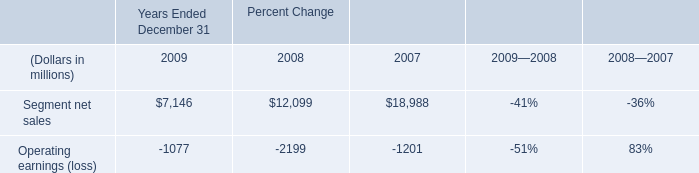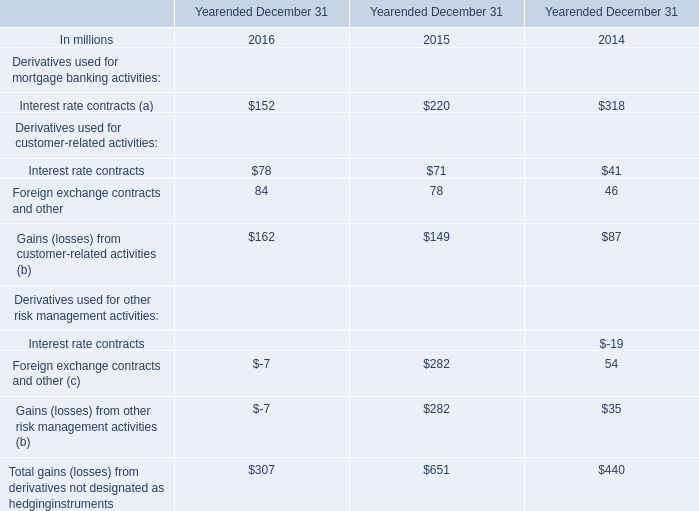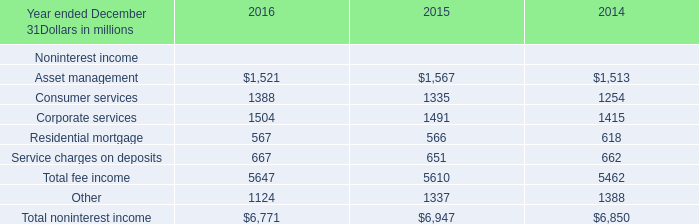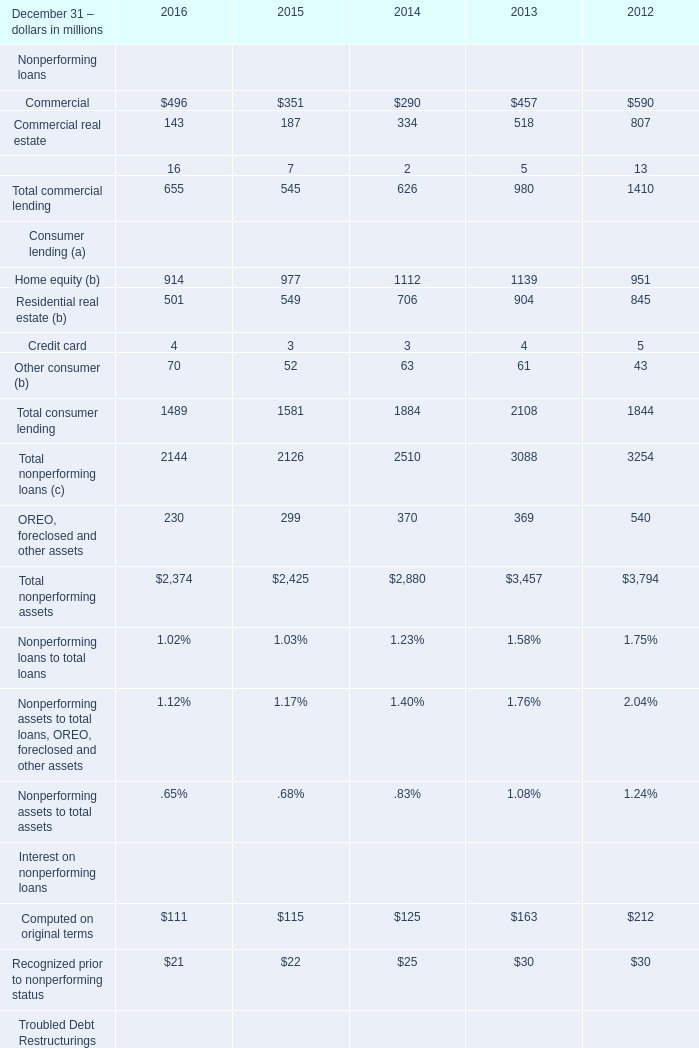Which year is Service charges on deposits the most? 
Answer: 2016. 